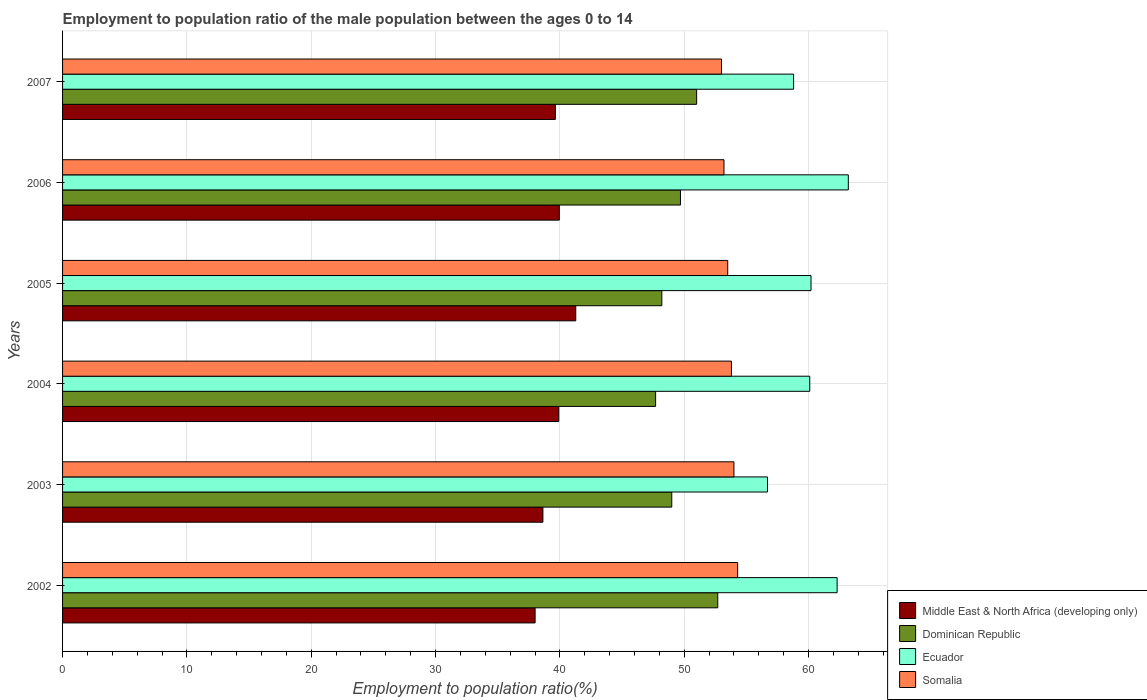How many different coloured bars are there?
Keep it short and to the point. 4. Are the number of bars per tick equal to the number of legend labels?
Offer a terse response. Yes. How many bars are there on the 6th tick from the top?
Make the answer very short. 4. What is the label of the 1st group of bars from the top?
Keep it short and to the point. 2007. Across all years, what is the maximum employment to population ratio in Somalia?
Provide a succinct answer. 54.3. Across all years, what is the minimum employment to population ratio in Ecuador?
Offer a terse response. 56.7. In which year was the employment to population ratio in Ecuador maximum?
Make the answer very short. 2006. In which year was the employment to population ratio in Ecuador minimum?
Keep it short and to the point. 2003. What is the total employment to population ratio in Dominican Republic in the graph?
Keep it short and to the point. 298.3. What is the difference between the employment to population ratio in Ecuador in 2002 and that in 2003?
Your answer should be compact. 5.6. What is the difference between the employment to population ratio in Dominican Republic in 2005 and the employment to population ratio in Middle East & North Africa (developing only) in 2007?
Your answer should be very brief. 8.56. What is the average employment to population ratio in Somalia per year?
Your response must be concise. 53.63. In the year 2004, what is the difference between the employment to population ratio in Dominican Republic and employment to population ratio in Somalia?
Make the answer very short. -6.1. In how many years, is the employment to population ratio in Dominican Republic greater than 10 %?
Give a very brief answer. 6. What is the ratio of the employment to population ratio in Somalia in 2006 to that in 2007?
Ensure brevity in your answer.  1. Is the employment to population ratio in Somalia in 2002 less than that in 2003?
Your response must be concise. No. What is the difference between the highest and the second highest employment to population ratio in Somalia?
Your answer should be very brief. 0.3. In how many years, is the employment to population ratio in Ecuador greater than the average employment to population ratio in Ecuador taken over all years?
Provide a succinct answer. 2. Is it the case that in every year, the sum of the employment to population ratio in Dominican Republic and employment to population ratio in Ecuador is greater than the sum of employment to population ratio in Somalia and employment to population ratio in Middle East & North Africa (developing only)?
Offer a very short reply. No. What does the 2nd bar from the top in 2007 represents?
Offer a terse response. Ecuador. What does the 3rd bar from the bottom in 2004 represents?
Provide a short and direct response. Ecuador. How many bars are there?
Make the answer very short. 24. How many years are there in the graph?
Give a very brief answer. 6. What is the difference between two consecutive major ticks on the X-axis?
Give a very brief answer. 10. Are the values on the major ticks of X-axis written in scientific E-notation?
Offer a terse response. No. Does the graph contain any zero values?
Make the answer very short. No. Does the graph contain grids?
Provide a short and direct response. Yes. Where does the legend appear in the graph?
Your answer should be compact. Bottom right. How many legend labels are there?
Keep it short and to the point. 4. How are the legend labels stacked?
Your answer should be compact. Vertical. What is the title of the graph?
Your response must be concise. Employment to population ratio of the male population between the ages 0 to 14. What is the label or title of the X-axis?
Provide a short and direct response. Employment to population ratio(%). What is the Employment to population ratio(%) in Middle East & North Africa (developing only) in 2002?
Provide a short and direct response. 38.01. What is the Employment to population ratio(%) in Dominican Republic in 2002?
Provide a succinct answer. 52.7. What is the Employment to population ratio(%) in Ecuador in 2002?
Offer a terse response. 62.3. What is the Employment to population ratio(%) in Somalia in 2002?
Give a very brief answer. 54.3. What is the Employment to population ratio(%) in Middle East & North Africa (developing only) in 2003?
Provide a succinct answer. 38.63. What is the Employment to population ratio(%) of Dominican Republic in 2003?
Give a very brief answer. 49. What is the Employment to population ratio(%) in Ecuador in 2003?
Your answer should be very brief. 56.7. What is the Employment to population ratio(%) of Middle East & North Africa (developing only) in 2004?
Keep it short and to the point. 39.91. What is the Employment to population ratio(%) of Dominican Republic in 2004?
Offer a very short reply. 47.7. What is the Employment to population ratio(%) in Ecuador in 2004?
Offer a very short reply. 60.1. What is the Employment to population ratio(%) in Somalia in 2004?
Offer a very short reply. 53.8. What is the Employment to population ratio(%) in Middle East & North Africa (developing only) in 2005?
Provide a succinct answer. 41.28. What is the Employment to population ratio(%) in Dominican Republic in 2005?
Your answer should be very brief. 48.2. What is the Employment to population ratio(%) in Ecuador in 2005?
Your response must be concise. 60.2. What is the Employment to population ratio(%) of Somalia in 2005?
Make the answer very short. 53.5. What is the Employment to population ratio(%) of Middle East & North Africa (developing only) in 2006?
Make the answer very short. 39.95. What is the Employment to population ratio(%) in Dominican Republic in 2006?
Keep it short and to the point. 49.7. What is the Employment to population ratio(%) of Ecuador in 2006?
Your answer should be compact. 63.2. What is the Employment to population ratio(%) of Somalia in 2006?
Keep it short and to the point. 53.2. What is the Employment to population ratio(%) in Middle East & North Africa (developing only) in 2007?
Offer a terse response. 39.64. What is the Employment to population ratio(%) of Ecuador in 2007?
Offer a terse response. 58.8. What is the Employment to population ratio(%) in Somalia in 2007?
Offer a terse response. 53. Across all years, what is the maximum Employment to population ratio(%) of Middle East & North Africa (developing only)?
Offer a very short reply. 41.28. Across all years, what is the maximum Employment to population ratio(%) in Dominican Republic?
Give a very brief answer. 52.7. Across all years, what is the maximum Employment to population ratio(%) in Ecuador?
Provide a succinct answer. 63.2. Across all years, what is the maximum Employment to population ratio(%) of Somalia?
Offer a very short reply. 54.3. Across all years, what is the minimum Employment to population ratio(%) of Middle East & North Africa (developing only)?
Make the answer very short. 38.01. Across all years, what is the minimum Employment to population ratio(%) of Dominican Republic?
Keep it short and to the point. 47.7. Across all years, what is the minimum Employment to population ratio(%) in Ecuador?
Provide a succinct answer. 56.7. Across all years, what is the minimum Employment to population ratio(%) of Somalia?
Make the answer very short. 53. What is the total Employment to population ratio(%) of Middle East & North Africa (developing only) in the graph?
Your answer should be compact. 237.42. What is the total Employment to population ratio(%) of Dominican Republic in the graph?
Offer a terse response. 298.3. What is the total Employment to population ratio(%) of Ecuador in the graph?
Your response must be concise. 361.3. What is the total Employment to population ratio(%) in Somalia in the graph?
Give a very brief answer. 321.8. What is the difference between the Employment to population ratio(%) in Middle East & North Africa (developing only) in 2002 and that in 2003?
Ensure brevity in your answer.  -0.63. What is the difference between the Employment to population ratio(%) in Dominican Republic in 2002 and that in 2003?
Ensure brevity in your answer.  3.7. What is the difference between the Employment to population ratio(%) in Somalia in 2002 and that in 2003?
Provide a short and direct response. 0.3. What is the difference between the Employment to population ratio(%) of Middle East & North Africa (developing only) in 2002 and that in 2004?
Provide a succinct answer. -1.9. What is the difference between the Employment to population ratio(%) in Ecuador in 2002 and that in 2004?
Make the answer very short. 2.2. What is the difference between the Employment to population ratio(%) of Somalia in 2002 and that in 2004?
Your response must be concise. 0.5. What is the difference between the Employment to population ratio(%) in Middle East & North Africa (developing only) in 2002 and that in 2005?
Offer a very short reply. -3.27. What is the difference between the Employment to population ratio(%) of Somalia in 2002 and that in 2005?
Your response must be concise. 0.8. What is the difference between the Employment to population ratio(%) of Middle East & North Africa (developing only) in 2002 and that in 2006?
Make the answer very short. -1.95. What is the difference between the Employment to population ratio(%) of Dominican Republic in 2002 and that in 2006?
Your answer should be very brief. 3. What is the difference between the Employment to population ratio(%) in Middle East & North Africa (developing only) in 2002 and that in 2007?
Give a very brief answer. -1.63. What is the difference between the Employment to population ratio(%) in Dominican Republic in 2002 and that in 2007?
Give a very brief answer. 1.7. What is the difference between the Employment to population ratio(%) in Somalia in 2002 and that in 2007?
Offer a terse response. 1.3. What is the difference between the Employment to population ratio(%) in Middle East & North Africa (developing only) in 2003 and that in 2004?
Give a very brief answer. -1.28. What is the difference between the Employment to population ratio(%) of Ecuador in 2003 and that in 2004?
Ensure brevity in your answer.  -3.4. What is the difference between the Employment to population ratio(%) in Middle East & North Africa (developing only) in 2003 and that in 2005?
Provide a short and direct response. -2.64. What is the difference between the Employment to population ratio(%) of Dominican Republic in 2003 and that in 2005?
Your response must be concise. 0.8. What is the difference between the Employment to population ratio(%) of Middle East & North Africa (developing only) in 2003 and that in 2006?
Offer a terse response. -1.32. What is the difference between the Employment to population ratio(%) of Somalia in 2003 and that in 2006?
Ensure brevity in your answer.  0.8. What is the difference between the Employment to population ratio(%) in Middle East & North Africa (developing only) in 2003 and that in 2007?
Provide a short and direct response. -1. What is the difference between the Employment to population ratio(%) in Dominican Republic in 2003 and that in 2007?
Provide a short and direct response. -2. What is the difference between the Employment to population ratio(%) of Ecuador in 2003 and that in 2007?
Offer a very short reply. -2.1. What is the difference between the Employment to population ratio(%) of Middle East & North Africa (developing only) in 2004 and that in 2005?
Your answer should be very brief. -1.37. What is the difference between the Employment to population ratio(%) of Dominican Republic in 2004 and that in 2005?
Give a very brief answer. -0.5. What is the difference between the Employment to population ratio(%) of Middle East & North Africa (developing only) in 2004 and that in 2006?
Make the answer very short. -0.04. What is the difference between the Employment to population ratio(%) of Somalia in 2004 and that in 2006?
Your answer should be very brief. 0.6. What is the difference between the Employment to population ratio(%) of Middle East & North Africa (developing only) in 2004 and that in 2007?
Ensure brevity in your answer.  0.27. What is the difference between the Employment to population ratio(%) of Middle East & North Africa (developing only) in 2005 and that in 2006?
Offer a very short reply. 1.32. What is the difference between the Employment to population ratio(%) of Dominican Republic in 2005 and that in 2006?
Offer a very short reply. -1.5. What is the difference between the Employment to population ratio(%) in Ecuador in 2005 and that in 2006?
Your answer should be compact. -3. What is the difference between the Employment to population ratio(%) of Middle East & North Africa (developing only) in 2005 and that in 2007?
Provide a succinct answer. 1.64. What is the difference between the Employment to population ratio(%) of Middle East & North Africa (developing only) in 2006 and that in 2007?
Offer a very short reply. 0.32. What is the difference between the Employment to population ratio(%) in Dominican Republic in 2006 and that in 2007?
Offer a very short reply. -1.3. What is the difference between the Employment to population ratio(%) in Middle East & North Africa (developing only) in 2002 and the Employment to population ratio(%) in Dominican Republic in 2003?
Your answer should be very brief. -10.99. What is the difference between the Employment to population ratio(%) in Middle East & North Africa (developing only) in 2002 and the Employment to population ratio(%) in Ecuador in 2003?
Give a very brief answer. -18.69. What is the difference between the Employment to population ratio(%) of Middle East & North Africa (developing only) in 2002 and the Employment to population ratio(%) of Somalia in 2003?
Give a very brief answer. -15.99. What is the difference between the Employment to population ratio(%) of Dominican Republic in 2002 and the Employment to population ratio(%) of Ecuador in 2003?
Your answer should be compact. -4. What is the difference between the Employment to population ratio(%) of Dominican Republic in 2002 and the Employment to population ratio(%) of Somalia in 2003?
Your answer should be very brief. -1.3. What is the difference between the Employment to population ratio(%) in Middle East & North Africa (developing only) in 2002 and the Employment to population ratio(%) in Dominican Republic in 2004?
Your answer should be compact. -9.69. What is the difference between the Employment to population ratio(%) in Middle East & North Africa (developing only) in 2002 and the Employment to population ratio(%) in Ecuador in 2004?
Keep it short and to the point. -22.09. What is the difference between the Employment to population ratio(%) of Middle East & North Africa (developing only) in 2002 and the Employment to population ratio(%) of Somalia in 2004?
Your response must be concise. -15.79. What is the difference between the Employment to population ratio(%) of Ecuador in 2002 and the Employment to population ratio(%) of Somalia in 2004?
Your answer should be compact. 8.5. What is the difference between the Employment to population ratio(%) of Middle East & North Africa (developing only) in 2002 and the Employment to population ratio(%) of Dominican Republic in 2005?
Offer a very short reply. -10.19. What is the difference between the Employment to population ratio(%) in Middle East & North Africa (developing only) in 2002 and the Employment to population ratio(%) in Ecuador in 2005?
Your answer should be compact. -22.19. What is the difference between the Employment to population ratio(%) of Middle East & North Africa (developing only) in 2002 and the Employment to population ratio(%) of Somalia in 2005?
Your response must be concise. -15.49. What is the difference between the Employment to population ratio(%) in Ecuador in 2002 and the Employment to population ratio(%) in Somalia in 2005?
Make the answer very short. 8.8. What is the difference between the Employment to population ratio(%) in Middle East & North Africa (developing only) in 2002 and the Employment to population ratio(%) in Dominican Republic in 2006?
Ensure brevity in your answer.  -11.69. What is the difference between the Employment to population ratio(%) of Middle East & North Africa (developing only) in 2002 and the Employment to population ratio(%) of Ecuador in 2006?
Make the answer very short. -25.19. What is the difference between the Employment to population ratio(%) of Middle East & North Africa (developing only) in 2002 and the Employment to population ratio(%) of Somalia in 2006?
Make the answer very short. -15.19. What is the difference between the Employment to population ratio(%) of Dominican Republic in 2002 and the Employment to population ratio(%) of Somalia in 2006?
Your response must be concise. -0.5. What is the difference between the Employment to population ratio(%) of Middle East & North Africa (developing only) in 2002 and the Employment to population ratio(%) of Dominican Republic in 2007?
Keep it short and to the point. -12.99. What is the difference between the Employment to population ratio(%) of Middle East & North Africa (developing only) in 2002 and the Employment to population ratio(%) of Ecuador in 2007?
Provide a succinct answer. -20.79. What is the difference between the Employment to population ratio(%) in Middle East & North Africa (developing only) in 2002 and the Employment to population ratio(%) in Somalia in 2007?
Ensure brevity in your answer.  -14.99. What is the difference between the Employment to population ratio(%) in Dominican Republic in 2002 and the Employment to population ratio(%) in Ecuador in 2007?
Provide a succinct answer. -6.1. What is the difference between the Employment to population ratio(%) in Dominican Republic in 2002 and the Employment to population ratio(%) in Somalia in 2007?
Make the answer very short. -0.3. What is the difference between the Employment to population ratio(%) of Ecuador in 2002 and the Employment to population ratio(%) of Somalia in 2007?
Provide a short and direct response. 9.3. What is the difference between the Employment to population ratio(%) of Middle East & North Africa (developing only) in 2003 and the Employment to population ratio(%) of Dominican Republic in 2004?
Provide a short and direct response. -9.06. What is the difference between the Employment to population ratio(%) of Middle East & North Africa (developing only) in 2003 and the Employment to population ratio(%) of Ecuador in 2004?
Keep it short and to the point. -21.46. What is the difference between the Employment to population ratio(%) in Middle East & North Africa (developing only) in 2003 and the Employment to population ratio(%) in Somalia in 2004?
Your answer should be very brief. -15.16. What is the difference between the Employment to population ratio(%) in Dominican Republic in 2003 and the Employment to population ratio(%) in Somalia in 2004?
Keep it short and to the point. -4.8. What is the difference between the Employment to population ratio(%) of Middle East & North Africa (developing only) in 2003 and the Employment to population ratio(%) of Dominican Republic in 2005?
Provide a short and direct response. -9.56. What is the difference between the Employment to population ratio(%) of Middle East & North Africa (developing only) in 2003 and the Employment to population ratio(%) of Ecuador in 2005?
Your answer should be compact. -21.57. What is the difference between the Employment to population ratio(%) of Middle East & North Africa (developing only) in 2003 and the Employment to population ratio(%) of Somalia in 2005?
Your answer should be compact. -14.87. What is the difference between the Employment to population ratio(%) of Middle East & North Africa (developing only) in 2003 and the Employment to population ratio(%) of Dominican Republic in 2006?
Offer a very short reply. -11.06. What is the difference between the Employment to population ratio(%) in Middle East & North Africa (developing only) in 2003 and the Employment to population ratio(%) in Ecuador in 2006?
Keep it short and to the point. -24.57. What is the difference between the Employment to population ratio(%) in Middle East & North Africa (developing only) in 2003 and the Employment to population ratio(%) in Somalia in 2006?
Ensure brevity in your answer.  -14.56. What is the difference between the Employment to population ratio(%) of Dominican Republic in 2003 and the Employment to population ratio(%) of Ecuador in 2006?
Your answer should be very brief. -14.2. What is the difference between the Employment to population ratio(%) of Dominican Republic in 2003 and the Employment to population ratio(%) of Somalia in 2006?
Provide a succinct answer. -4.2. What is the difference between the Employment to population ratio(%) in Middle East & North Africa (developing only) in 2003 and the Employment to population ratio(%) in Dominican Republic in 2007?
Offer a very short reply. -12.37. What is the difference between the Employment to population ratio(%) of Middle East & North Africa (developing only) in 2003 and the Employment to population ratio(%) of Ecuador in 2007?
Ensure brevity in your answer.  -20.16. What is the difference between the Employment to population ratio(%) in Middle East & North Africa (developing only) in 2003 and the Employment to population ratio(%) in Somalia in 2007?
Your answer should be very brief. -14.37. What is the difference between the Employment to population ratio(%) of Dominican Republic in 2003 and the Employment to population ratio(%) of Somalia in 2007?
Offer a very short reply. -4. What is the difference between the Employment to population ratio(%) in Ecuador in 2003 and the Employment to population ratio(%) in Somalia in 2007?
Your response must be concise. 3.7. What is the difference between the Employment to population ratio(%) in Middle East & North Africa (developing only) in 2004 and the Employment to population ratio(%) in Dominican Republic in 2005?
Your answer should be compact. -8.29. What is the difference between the Employment to population ratio(%) of Middle East & North Africa (developing only) in 2004 and the Employment to population ratio(%) of Ecuador in 2005?
Offer a terse response. -20.29. What is the difference between the Employment to population ratio(%) in Middle East & North Africa (developing only) in 2004 and the Employment to population ratio(%) in Somalia in 2005?
Your answer should be very brief. -13.59. What is the difference between the Employment to population ratio(%) in Ecuador in 2004 and the Employment to population ratio(%) in Somalia in 2005?
Make the answer very short. 6.6. What is the difference between the Employment to population ratio(%) in Middle East & North Africa (developing only) in 2004 and the Employment to population ratio(%) in Dominican Republic in 2006?
Provide a succinct answer. -9.79. What is the difference between the Employment to population ratio(%) of Middle East & North Africa (developing only) in 2004 and the Employment to population ratio(%) of Ecuador in 2006?
Make the answer very short. -23.29. What is the difference between the Employment to population ratio(%) in Middle East & North Africa (developing only) in 2004 and the Employment to population ratio(%) in Somalia in 2006?
Provide a succinct answer. -13.29. What is the difference between the Employment to population ratio(%) of Dominican Republic in 2004 and the Employment to population ratio(%) of Ecuador in 2006?
Keep it short and to the point. -15.5. What is the difference between the Employment to population ratio(%) of Middle East & North Africa (developing only) in 2004 and the Employment to population ratio(%) of Dominican Republic in 2007?
Offer a very short reply. -11.09. What is the difference between the Employment to population ratio(%) in Middle East & North Africa (developing only) in 2004 and the Employment to population ratio(%) in Ecuador in 2007?
Offer a terse response. -18.89. What is the difference between the Employment to population ratio(%) in Middle East & North Africa (developing only) in 2004 and the Employment to population ratio(%) in Somalia in 2007?
Provide a succinct answer. -13.09. What is the difference between the Employment to population ratio(%) of Dominican Republic in 2004 and the Employment to population ratio(%) of Somalia in 2007?
Ensure brevity in your answer.  -5.3. What is the difference between the Employment to population ratio(%) of Middle East & North Africa (developing only) in 2005 and the Employment to population ratio(%) of Dominican Republic in 2006?
Provide a short and direct response. -8.42. What is the difference between the Employment to population ratio(%) in Middle East & North Africa (developing only) in 2005 and the Employment to population ratio(%) in Ecuador in 2006?
Offer a very short reply. -21.92. What is the difference between the Employment to population ratio(%) of Middle East & North Africa (developing only) in 2005 and the Employment to population ratio(%) of Somalia in 2006?
Provide a short and direct response. -11.92. What is the difference between the Employment to population ratio(%) in Dominican Republic in 2005 and the Employment to population ratio(%) in Ecuador in 2006?
Offer a terse response. -15. What is the difference between the Employment to population ratio(%) of Dominican Republic in 2005 and the Employment to population ratio(%) of Somalia in 2006?
Make the answer very short. -5. What is the difference between the Employment to population ratio(%) in Ecuador in 2005 and the Employment to population ratio(%) in Somalia in 2006?
Provide a short and direct response. 7. What is the difference between the Employment to population ratio(%) in Middle East & North Africa (developing only) in 2005 and the Employment to population ratio(%) in Dominican Republic in 2007?
Your answer should be very brief. -9.72. What is the difference between the Employment to population ratio(%) in Middle East & North Africa (developing only) in 2005 and the Employment to population ratio(%) in Ecuador in 2007?
Keep it short and to the point. -17.52. What is the difference between the Employment to population ratio(%) of Middle East & North Africa (developing only) in 2005 and the Employment to population ratio(%) of Somalia in 2007?
Offer a terse response. -11.72. What is the difference between the Employment to population ratio(%) of Dominican Republic in 2005 and the Employment to population ratio(%) of Ecuador in 2007?
Make the answer very short. -10.6. What is the difference between the Employment to population ratio(%) of Ecuador in 2005 and the Employment to population ratio(%) of Somalia in 2007?
Offer a terse response. 7.2. What is the difference between the Employment to population ratio(%) of Middle East & North Africa (developing only) in 2006 and the Employment to population ratio(%) of Dominican Republic in 2007?
Your answer should be very brief. -11.05. What is the difference between the Employment to population ratio(%) of Middle East & North Africa (developing only) in 2006 and the Employment to population ratio(%) of Ecuador in 2007?
Your answer should be very brief. -18.85. What is the difference between the Employment to population ratio(%) of Middle East & North Africa (developing only) in 2006 and the Employment to population ratio(%) of Somalia in 2007?
Ensure brevity in your answer.  -13.05. What is the difference between the Employment to population ratio(%) in Dominican Republic in 2006 and the Employment to population ratio(%) in Ecuador in 2007?
Your response must be concise. -9.1. What is the average Employment to population ratio(%) of Middle East & North Africa (developing only) per year?
Your response must be concise. 39.57. What is the average Employment to population ratio(%) in Dominican Republic per year?
Ensure brevity in your answer.  49.72. What is the average Employment to population ratio(%) of Ecuador per year?
Your answer should be very brief. 60.22. What is the average Employment to population ratio(%) in Somalia per year?
Offer a terse response. 53.63. In the year 2002, what is the difference between the Employment to population ratio(%) in Middle East & North Africa (developing only) and Employment to population ratio(%) in Dominican Republic?
Ensure brevity in your answer.  -14.69. In the year 2002, what is the difference between the Employment to population ratio(%) of Middle East & North Africa (developing only) and Employment to population ratio(%) of Ecuador?
Give a very brief answer. -24.29. In the year 2002, what is the difference between the Employment to population ratio(%) in Middle East & North Africa (developing only) and Employment to population ratio(%) in Somalia?
Ensure brevity in your answer.  -16.29. In the year 2002, what is the difference between the Employment to population ratio(%) in Dominican Republic and Employment to population ratio(%) in Somalia?
Keep it short and to the point. -1.6. In the year 2002, what is the difference between the Employment to population ratio(%) in Ecuador and Employment to population ratio(%) in Somalia?
Your answer should be compact. 8. In the year 2003, what is the difference between the Employment to population ratio(%) in Middle East & North Africa (developing only) and Employment to population ratio(%) in Dominican Republic?
Your response must be concise. -10.37. In the year 2003, what is the difference between the Employment to population ratio(%) in Middle East & North Africa (developing only) and Employment to population ratio(%) in Ecuador?
Keep it short and to the point. -18.07. In the year 2003, what is the difference between the Employment to population ratio(%) of Middle East & North Africa (developing only) and Employment to population ratio(%) of Somalia?
Provide a short and direct response. -15.37. In the year 2004, what is the difference between the Employment to population ratio(%) in Middle East & North Africa (developing only) and Employment to population ratio(%) in Dominican Republic?
Offer a terse response. -7.79. In the year 2004, what is the difference between the Employment to population ratio(%) in Middle East & North Africa (developing only) and Employment to population ratio(%) in Ecuador?
Offer a terse response. -20.19. In the year 2004, what is the difference between the Employment to population ratio(%) of Middle East & North Africa (developing only) and Employment to population ratio(%) of Somalia?
Ensure brevity in your answer.  -13.89. In the year 2004, what is the difference between the Employment to population ratio(%) in Ecuador and Employment to population ratio(%) in Somalia?
Your answer should be compact. 6.3. In the year 2005, what is the difference between the Employment to population ratio(%) of Middle East & North Africa (developing only) and Employment to population ratio(%) of Dominican Republic?
Keep it short and to the point. -6.92. In the year 2005, what is the difference between the Employment to population ratio(%) of Middle East & North Africa (developing only) and Employment to population ratio(%) of Ecuador?
Make the answer very short. -18.92. In the year 2005, what is the difference between the Employment to population ratio(%) of Middle East & North Africa (developing only) and Employment to population ratio(%) of Somalia?
Your answer should be compact. -12.22. In the year 2005, what is the difference between the Employment to population ratio(%) of Dominican Republic and Employment to population ratio(%) of Ecuador?
Your answer should be very brief. -12. In the year 2005, what is the difference between the Employment to population ratio(%) in Dominican Republic and Employment to population ratio(%) in Somalia?
Offer a terse response. -5.3. In the year 2006, what is the difference between the Employment to population ratio(%) of Middle East & North Africa (developing only) and Employment to population ratio(%) of Dominican Republic?
Offer a very short reply. -9.75. In the year 2006, what is the difference between the Employment to population ratio(%) of Middle East & North Africa (developing only) and Employment to population ratio(%) of Ecuador?
Your response must be concise. -23.25. In the year 2006, what is the difference between the Employment to population ratio(%) of Middle East & North Africa (developing only) and Employment to population ratio(%) of Somalia?
Ensure brevity in your answer.  -13.25. In the year 2006, what is the difference between the Employment to population ratio(%) in Dominican Republic and Employment to population ratio(%) in Somalia?
Make the answer very short. -3.5. In the year 2007, what is the difference between the Employment to population ratio(%) of Middle East & North Africa (developing only) and Employment to population ratio(%) of Dominican Republic?
Provide a succinct answer. -11.36. In the year 2007, what is the difference between the Employment to population ratio(%) in Middle East & North Africa (developing only) and Employment to population ratio(%) in Ecuador?
Give a very brief answer. -19.16. In the year 2007, what is the difference between the Employment to population ratio(%) in Middle East & North Africa (developing only) and Employment to population ratio(%) in Somalia?
Keep it short and to the point. -13.36. What is the ratio of the Employment to population ratio(%) of Middle East & North Africa (developing only) in 2002 to that in 2003?
Make the answer very short. 0.98. What is the ratio of the Employment to population ratio(%) in Dominican Republic in 2002 to that in 2003?
Your answer should be compact. 1.08. What is the ratio of the Employment to population ratio(%) in Ecuador in 2002 to that in 2003?
Your answer should be very brief. 1.1. What is the ratio of the Employment to population ratio(%) of Somalia in 2002 to that in 2003?
Provide a short and direct response. 1.01. What is the ratio of the Employment to population ratio(%) of Middle East & North Africa (developing only) in 2002 to that in 2004?
Offer a terse response. 0.95. What is the ratio of the Employment to population ratio(%) of Dominican Republic in 2002 to that in 2004?
Provide a succinct answer. 1.1. What is the ratio of the Employment to population ratio(%) in Ecuador in 2002 to that in 2004?
Offer a terse response. 1.04. What is the ratio of the Employment to population ratio(%) in Somalia in 2002 to that in 2004?
Your answer should be very brief. 1.01. What is the ratio of the Employment to population ratio(%) of Middle East & North Africa (developing only) in 2002 to that in 2005?
Offer a very short reply. 0.92. What is the ratio of the Employment to population ratio(%) of Dominican Republic in 2002 to that in 2005?
Make the answer very short. 1.09. What is the ratio of the Employment to population ratio(%) of Ecuador in 2002 to that in 2005?
Your answer should be compact. 1.03. What is the ratio of the Employment to population ratio(%) of Middle East & North Africa (developing only) in 2002 to that in 2006?
Keep it short and to the point. 0.95. What is the ratio of the Employment to population ratio(%) of Dominican Republic in 2002 to that in 2006?
Provide a short and direct response. 1.06. What is the ratio of the Employment to population ratio(%) in Ecuador in 2002 to that in 2006?
Make the answer very short. 0.99. What is the ratio of the Employment to population ratio(%) of Somalia in 2002 to that in 2006?
Ensure brevity in your answer.  1.02. What is the ratio of the Employment to population ratio(%) in Middle East & North Africa (developing only) in 2002 to that in 2007?
Your response must be concise. 0.96. What is the ratio of the Employment to population ratio(%) in Dominican Republic in 2002 to that in 2007?
Offer a terse response. 1.03. What is the ratio of the Employment to population ratio(%) of Ecuador in 2002 to that in 2007?
Provide a succinct answer. 1.06. What is the ratio of the Employment to population ratio(%) in Somalia in 2002 to that in 2007?
Provide a short and direct response. 1.02. What is the ratio of the Employment to population ratio(%) of Middle East & North Africa (developing only) in 2003 to that in 2004?
Make the answer very short. 0.97. What is the ratio of the Employment to population ratio(%) of Dominican Republic in 2003 to that in 2004?
Offer a very short reply. 1.03. What is the ratio of the Employment to population ratio(%) in Ecuador in 2003 to that in 2004?
Offer a very short reply. 0.94. What is the ratio of the Employment to population ratio(%) of Middle East & North Africa (developing only) in 2003 to that in 2005?
Your response must be concise. 0.94. What is the ratio of the Employment to population ratio(%) of Dominican Republic in 2003 to that in 2005?
Give a very brief answer. 1.02. What is the ratio of the Employment to population ratio(%) in Ecuador in 2003 to that in 2005?
Make the answer very short. 0.94. What is the ratio of the Employment to population ratio(%) of Somalia in 2003 to that in 2005?
Your answer should be very brief. 1.01. What is the ratio of the Employment to population ratio(%) in Middle East & North Africa (developing only) in 2003 to that in 2006?
Give a very brief answer. 0.97. What is the ratio of the Employment to population ratio(%) of Dominican Republic in 2003 to that in 2006?
Keep it short and to the point. 0.99. What is the ratio of the Employment to population ratio(%) of Ecuador in 2003 to that in 2006?
Offer a very short reply. 0.9. What is the ratio of the Employment to population ratio(%) in Middle East & North Africa (developing only) in 2003 to that in 2007?
Keep it short and to the point. 0.97. What is the ratio of the Employment to population ratio(%) in Dominican Republic in 2003 to that in 2007?
Make the answer very short. 0.96. What is the ratio of the Employment to population ratio(%) in Somalia in 2003 to that in 2007?
Offer a terse response. 1.02. What is the ratio of the Employment to population ratio(%) in Middle East & North Africa (developing only) in 2004 to that in 2005?
Provide a succinct answer. 0.97. What is the ratio of the Employment to population ratio(%) of Dominican Republic in 2004 to that in 2005?
Your response must be concise. 0.99. What is the ratio of the Employment to population ratio(%) in Ecuador in 2004 to that in 2005?
Offer a terse response. 1. What is the ratio of the Employment to population ratio(%) of Somalia in 2004 to that in 2005?
Offer a terse response. 1.01. What is the ratio of the Employment to population ratio(%) of Middle East & North Africa (developing only) in 2004 to that in 2006?
Offer a very short reply. 1. What is the ratio of the Employment to population ratio(%) of Dominican Republic in 2004 to that in 2006?
Make the answer very short. 0.96. What is the ratio of the Employment to population ratio(%) in Ecuador in 2004 to that in 2006?
Offer a very short reply. 0.95. What is the ratio of the Employment to population ratio(%) in Somalia in 2004 to that in 2006?
Make the answer very short. 1.01. What is the ratio of the Employment to population ratio(%) in Middle East & North Africa (developing only) in 2004 to that in 2007?
Make the answer very short. 1.01. What is the ratio of the Employment to population ratio(%) in Dominican Republic in 2004 to that in 2007?
Your answer should be very brief. 0.94. What is the ratio of the Employment to population ratio(%) of Ecuador in 2004 to that in 2007?
Your answer should be compact. 1.02. What is the ratio of the Employment to population ratio(%) of Somalia in 2004 to that in 2007?
Your answer should be compact. 1.02. What is the ratio of the Employment to population ratio(%) of Middle East & North Africa (developing only) in 2005 to that in 2006?
Keep it short and to the point. 1.03. What is the ratio of the Employment to population ratio(%) of Dominican Republic in 2005 to that in 2006?
Keep it short and to the point. 0.97. What is the ratio of the Employment to population ratio(%) in Ecuador in 2005 to that in 2006?
Your answer should be very brief. 0.95. What is the ratio of the Employment to population ratio(%) in Somalia in 2005 to that in 2006?
Provide a short and direct response. 1.01. What is the ratio of the Employment to population ratio(%) in Middle East & North Africa (developing only) in 2005 to that in 2007?
Your response must be concise. 1.04. What is the ratio of the Employment to population ratio(%) of Dominican Republic in 2005 to that in 2007?
Give a very brief answer. 0.95. What is the ratio of the Employment to population ratio(%) in Ecuador in 2005 to that in 2007?
Your answer should be very brief. 1.02. What is the ratio of the Employment to population ratio(%) in Somalia in 2005 to that in 2007?
Ensure brevity in your answer.  1.01. What is the ratio of the Employment to population ratio(%) of Dominican Republic in 2006 to that in 2007?
Offer a terse response. 0.97. What is the ratio of the Employment to population ratio(%) of Ecuador in 2006 to that in 2007?
Make the answer very short. 1.07. What is the difference between the highest and the second highest Employment to population ratio(%) of Middle East & North Africa (developing only)?
Ensure brevity in your answer.  1.32. What is the difference between the highest and the second highest Employment to population ratio(%) of Dominican Republic?
Your answer should be very brief. 1.7. What is the difference between the highest and the second highest Employment to population ratio(%) in Somalia?
Your answer should be compact. 0.3. What is the difference between the highest and the lowest Employment to population ratio(%) of Middle East & North Africa (developing only)?
Provide a short and direct response. 3.27. What is the difference between the highest and the lowest Employment to population ratio(%) in Dominican Republic?
Ensure brevity in your answer.  5. What is the difference between the highest and the lowest Employment to population ratio(%) of Somalia?
Offer a terse response. 1.3. 